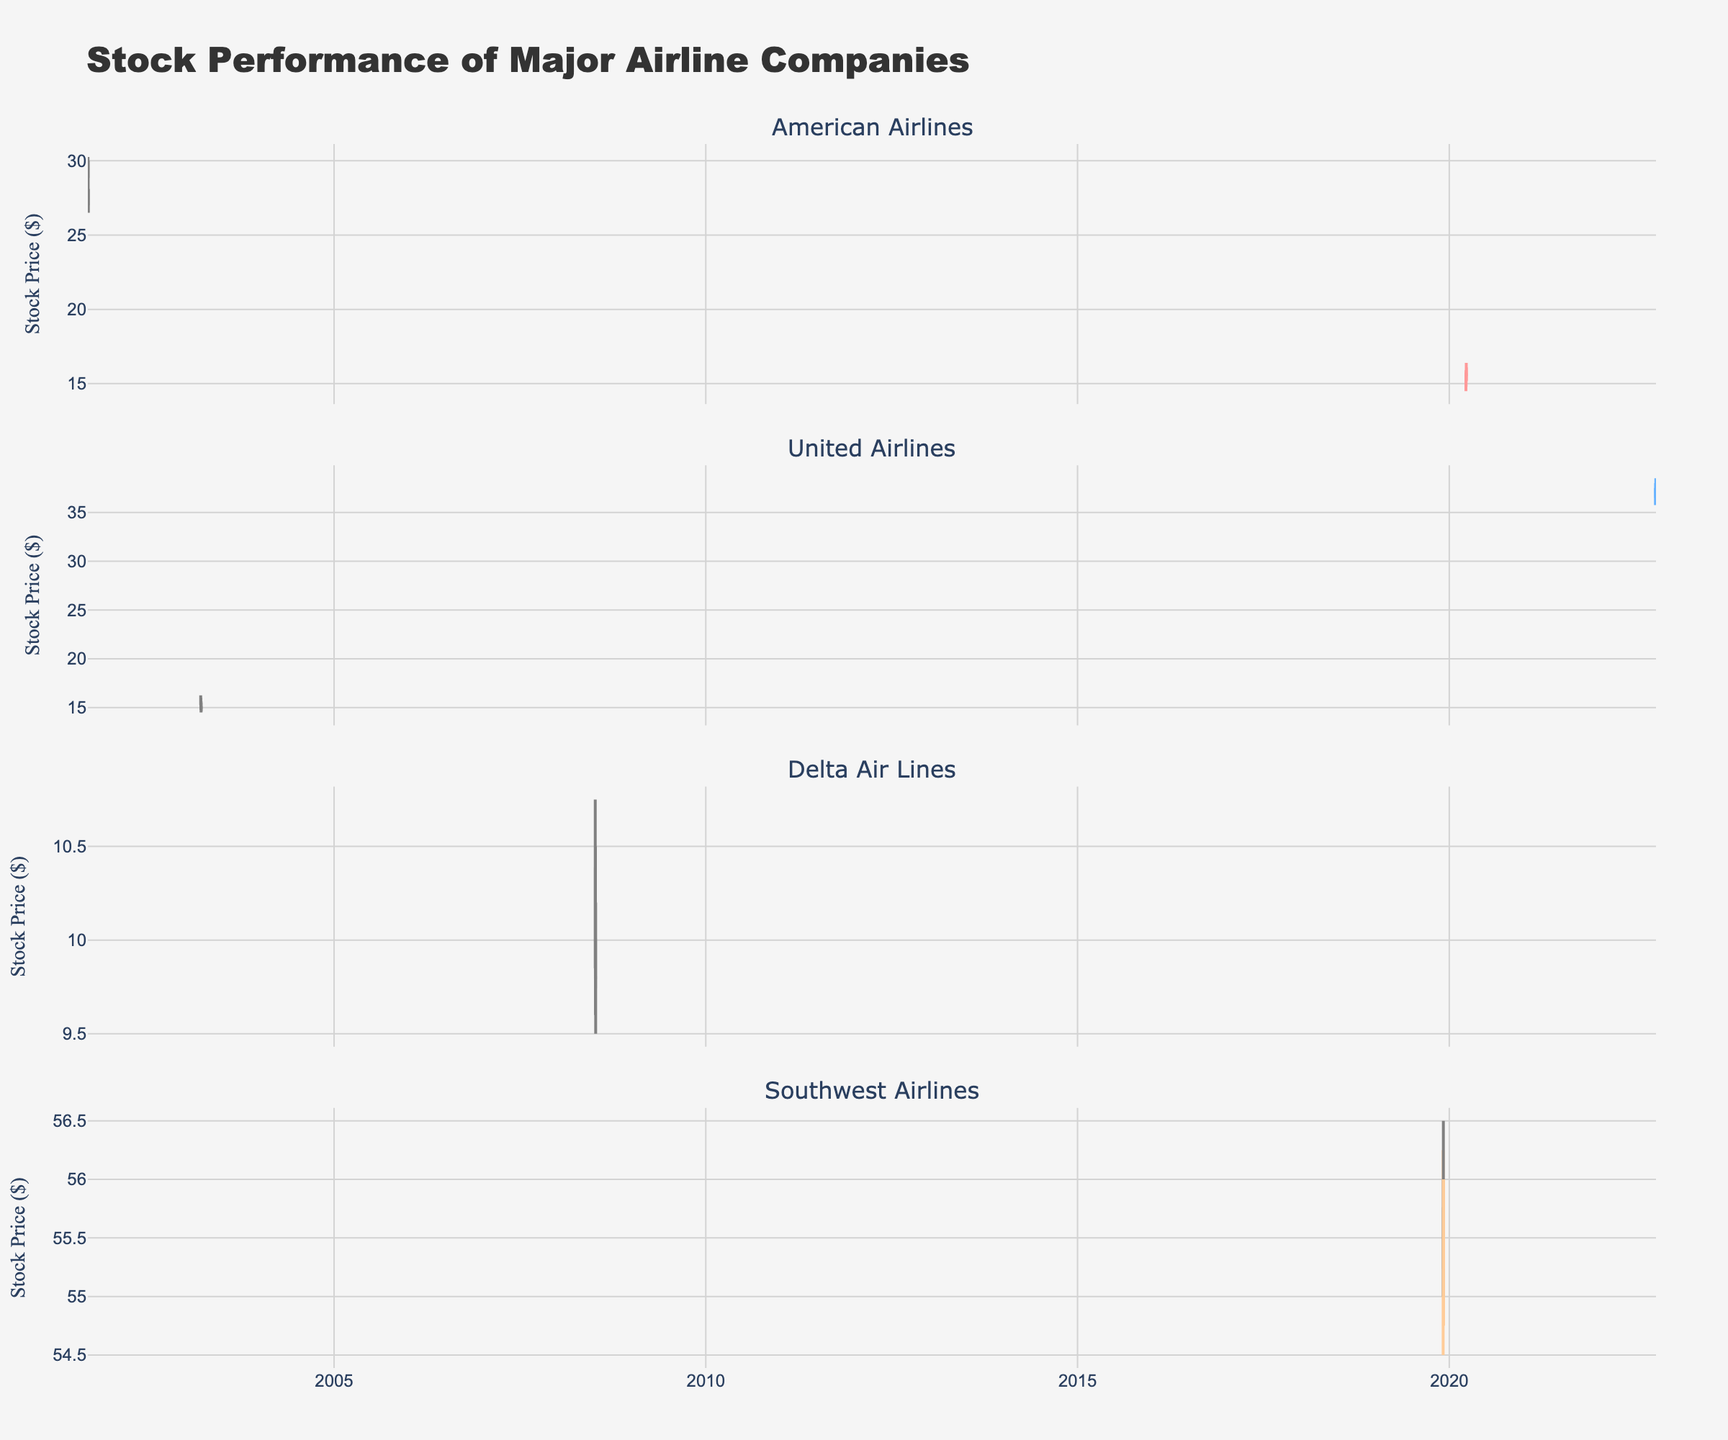What is the title of the figure? The title is typically located at the top center of the figure, providing a high-level summary of its content. In this case, the title is 'Stock Performance of Major Airline Companies.'
Answer: Stock Performance of Major Airline Companies How many companies' stock performances are shown in the figure? The subplot titles for each company's stock performance are displayed one above the other. By counting these titles, we can see there are four different companies: American Airlines, United Airlines, Delta Air Lines, and Southwest Airlines.
Answer: 4 Which airline company experienced the greatest decline in stock price on a single day? To find this, we compare the difference between the opening and closing prices for all companies on all days. The largest decline is observed for American Airlines on September 11, 2001, where the price dropped from 29.50 to 27.60.
Answer: American Airlines What is the range of stock prices for Delta Air Lines in July 2008? The range of stock prices can be found by identifying the highest high and the lowest low for Delta Air Lines during the specified period. From the data, the highest price is 10.75 and the lowest is 9.50. Thus, the range is 10.75 - 9.50.
Answer: 1.25 Which company had the highest closing price over the periods shown in the figure? For this question, we look at the closing prices for all companies and compare them. The highest closing price observed is for Southwest Airlines on December 2, 2019, at 55.75.
Answer: Southwest Airlines During the 2003 period, how did United Airlines' stock perform over the three-day span? First, we locate the three consecutive days in March 2003. On March 18, 2003, the closing price was 15.50. On March 19, it was 15.00, and on March 20, it dropped further to 14.75. Summarizing this, United Airlines' stock gradually declined over the three days.
Answer: Gradual decline Which company's stock experienced the sharpest increase relative to its volatilities in the given periods? By examining the candle patterns and comparing the differences in opening and closing prices relative to their volatility, American Airlines on March 25, 2020, saw a notable high increase where the stock closed at a significantly higher price than previous days. The stock increased from 15.60 to 16.00, showing a sharp increase relative to daily fluctuations.
Answer: American Airlines on March 25, 2020 What are the typical colors used to represent increasing and decreasing trends in the figure? The figure consistently uses specific colors to indicate trends. Green (or a light hue) generally signifies an increasing trend, while gray indicates a decreasing trend.
Answer: Green for increasing, Gray for decreasing 